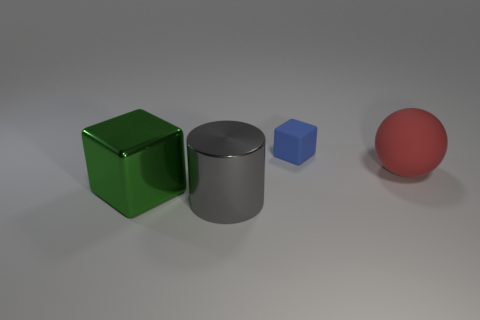Is the color of the metallic cylinder the same as the cube behind the large red matte thing?
Your response must be concise. No. How many things are either metal cylinders or big metal things in front of the large metal block?
Your answer should be very brief. 1. There is a block behind the big metal cube that is on the left side of the big ball; how big is it?
Provide a succinct answer. Small. Are there the same number of matte spheres behind the gray cylinder and red balls to the left of the blue rubber object?
Make the answer very short. No. There is a metal thing on the left side of the metal cylinder; are there any blue objects on the left side of it?
Provide a succinct answer. No. The red thing that is the same material as the tiny blue block is what shape?
Offer a very short reply. Sphere. Are there any other things of the same color as the matte sphere?
Your response must be concise. No. What is the material of the red ball in front of the rubber object that is behind the large red thing?
Provide a short and direct response. Rubber. Are there any red matte things that have the same shape as the large green thing?
Provide a succinct answer. No. How many other things are there of the same shape as the gray metal thing?
Ensure brevity in your answer.  0. 